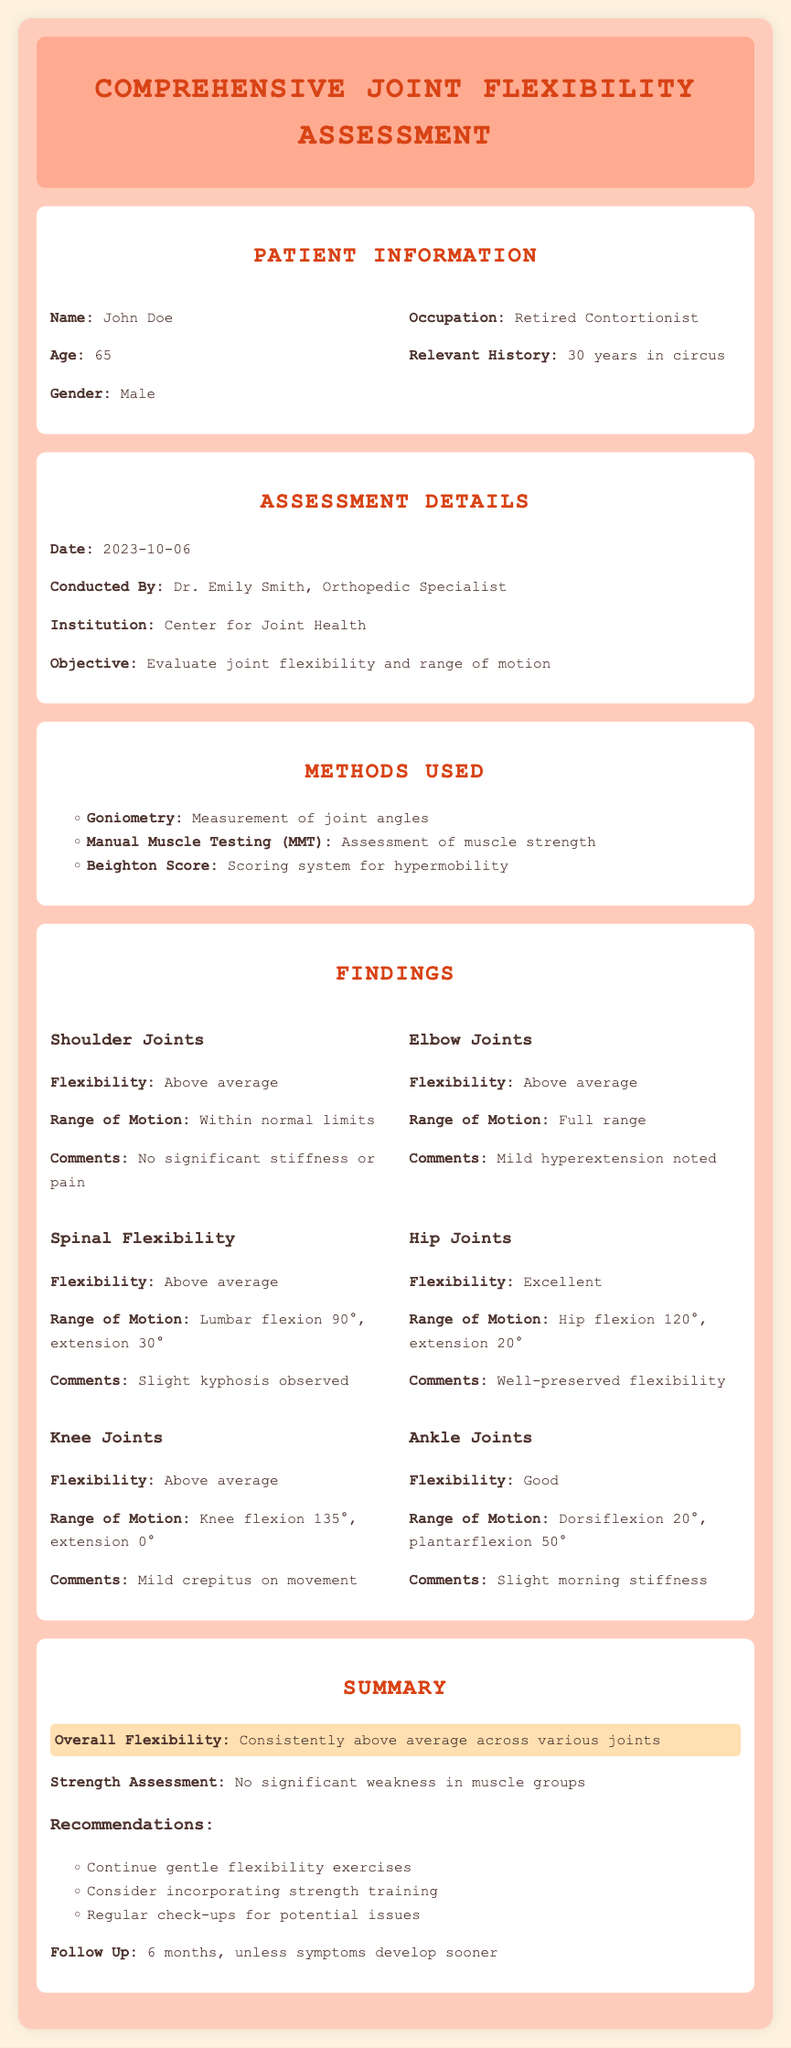What is the patient's name? The document lists the patient's name in the Patient Information section.
Answer: John Doe Who conducted the assessment? The document specifies the name of the medical professional who conducted the assessment.
Answer: Dr. Emily Smith What was the date of the assessment? The date is mentioned in the Assessment Details section of the document.
Answer: 2023-10-06 What is the overall flexibility assessment? This information is provided in the Summary section, highlighting the patient's general flexibility status.
Answer: Consistently above average across various joints What is the flexibility rating for the hip joints? The document includes specific findings for each joint, including the hip joints.
Answer: Excellent How many years did the patient work in the circus? This detail is provided under Relevant History in the Patient Information section.
Answer: 30 years What is the follow-up duration after the assessment? The follow-up time is mentioned in the Summary section.
Answer: 6 months What method was used to measure joint angles? The document lists specific assessment methods in the Methods Used section.
Answer: Goniometry What are the recommendations provided in the assessment? Recommendations are listed in the Summary section for ongoing care.
Answer: Continue gentle flexibility exercises, consider incorporating strength training, regular check-ups for potential issues 